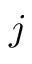<formula> <loc_0><loc_0><loc_500><loc_500>j</formula> 